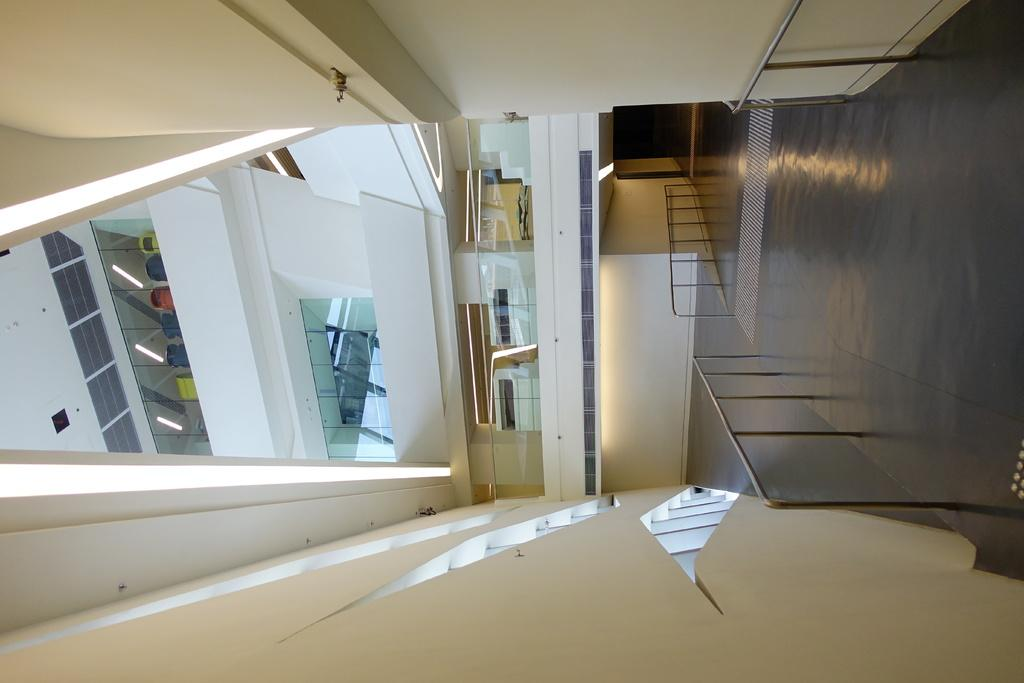What part of a building is shown in the image? The image shows the inner part of a building. What type of walls can be seen in the image? There are glass walls in the image. What can be used to illuminate the area in the image? Lights are visible in the image. What feature is present to provide safety or support? There is a railing in the image. What color is the wall in the image? The wall is in cream color. What type of fork is used to pay the tax in the image? There is no fork or tax mentioned in the image; it only shows the inner part of a building with glass walls, lights, a railing, and a cream-colored wall. 